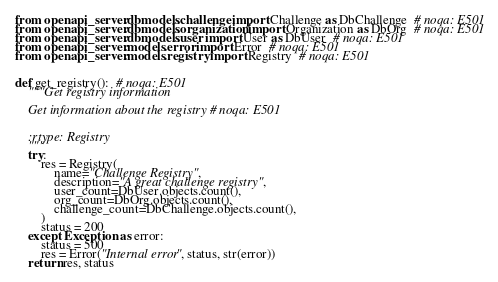<code> <loc_0><loc_0><loc_500><loc_500><_Python_>from openapi_server.dbmodels.challenge import Challenge as DbChallenge  # noqa: E501
from openapi_server.dbmodels.organization import Organization as DbOrg  # noqa: E501
from openapi_server.dbmodels.user import User as DbUser  # noqa: E501
from openapi_server.models.error import Error  # noqa: E501
from openapi_server.models.registry import Registry  # noqa: E501


def get_registry():  # noqa: E501
    """Get registry information

    Get information about the registry # noqa: E501


    :rtype: Registry
    """
    try:
        res = Registry(
            name="Challenge Registry",
            description="A great challenge registry",
            user_count=DbUser.objects.count(),
            org_count=DbOrg.objects.count(),
            challenge_count=DbChallenge.objects.count(),
        )
        status = 200
    except Exception as error:
        status = 500
        res = Error("Internal error", status, str(error))
    return res, status
</code> 